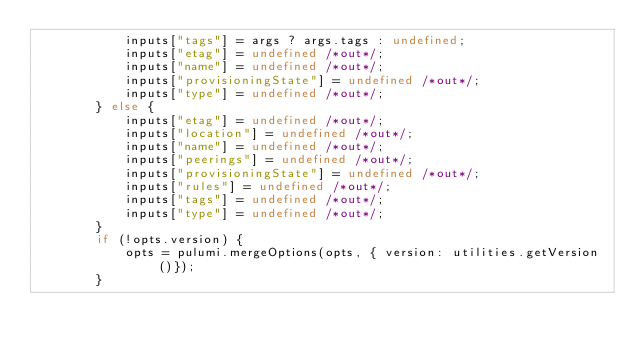<code> <loc_0><loc_0><loc_500><loc_500><_TypeScript_>            inputs["tags"] = args ? args.tags : undefined;
            inputs["etag"] = undefined /*out*/;
            inputs["name"] = undefined /*out*/;
            inputs["provisioningState"] = undefined /*out*/;
            inputs["type"] = undefined /*out*/;
        } else {
            inputs["etag"] = undefined /*out*/;
            inputs["location"] = undefined /*out*/;
            inputs["name"] = undefined /*out*/;
            inputs["peerings"] = undefined /*out*/;
            inputs["provisioningState"] = undefined /*out*/;
            inputs["rules"] = undefined /*out*/;
            inputs["tags"] = undefined /*out*/;
            inputs["type"] = undefined /*out*/;
        }
        if (!opts.version) {
            opts = pulumi.mergeOptions(opts, { version: utilities.getVersion()});
        }</code> 